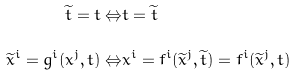<formula> <loc_0><loc_0><loc_500><loc_500>\widetilde { t } = t \Leftrightarrow & t = \widetilde { t } \\ \widetilde { x } ^ { i } = g ^ { i } ( x ^ { j } , t ) \Leftrightarrow & x ^ { i } = f ^ { i } ( \widetilde { x } ^ { j } , \widetilde { t } ) = f ^ { i } ( \widetilde { x } ^ { j } , t )</formula> 